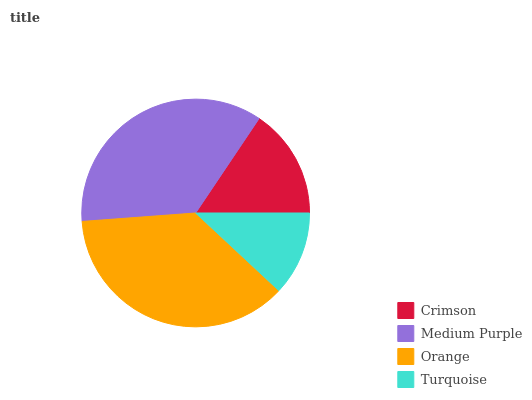Is Turquoise the minimum?
Answer yes or no. Yes. Is Orange the maximum?
Answer yes or no. Yes. Is Medium Purple the minimum?
Answer yes or no. No. Is Medium Purple the maximum?
Answer yes or no. No. Is Medium Purple greater than Crimson?
Answer yes or no. Yes. Is Crimson less than Medium Purple?
Answer yes or no. Yes. Is Crimson greater than Medium Purple?
Answer yes or no. No. Is Medium Purple less than Crimson?
Answer yes or no. No. Is Medium Purple the high median?
Answer yes or no. Yes. Is Crimson the low median?
Answer yes or no. Yes. Is Turquoise the high median?
Answer yes or no. No. Is Turquoise the low median?
Answer yes or no. No. 